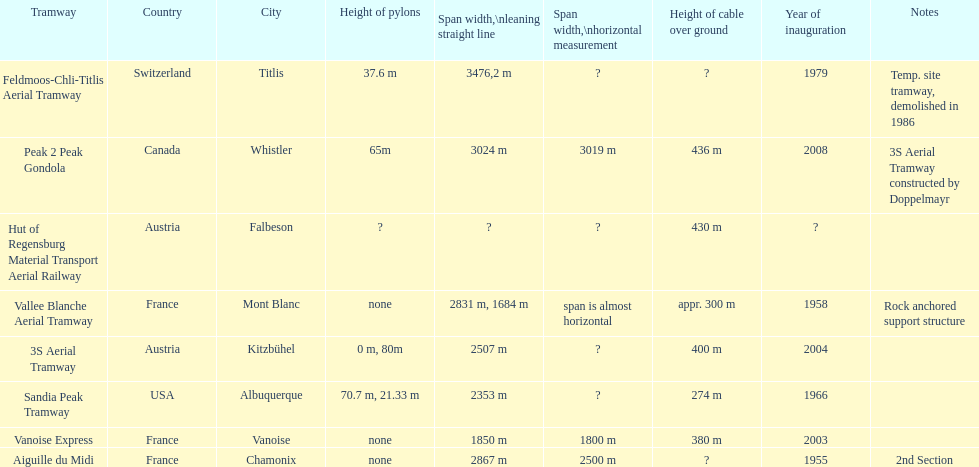How much greater is the height of cable over ground measurement for the peak 2 peak gondola when compared with that of the vanoise express? 56 m. 